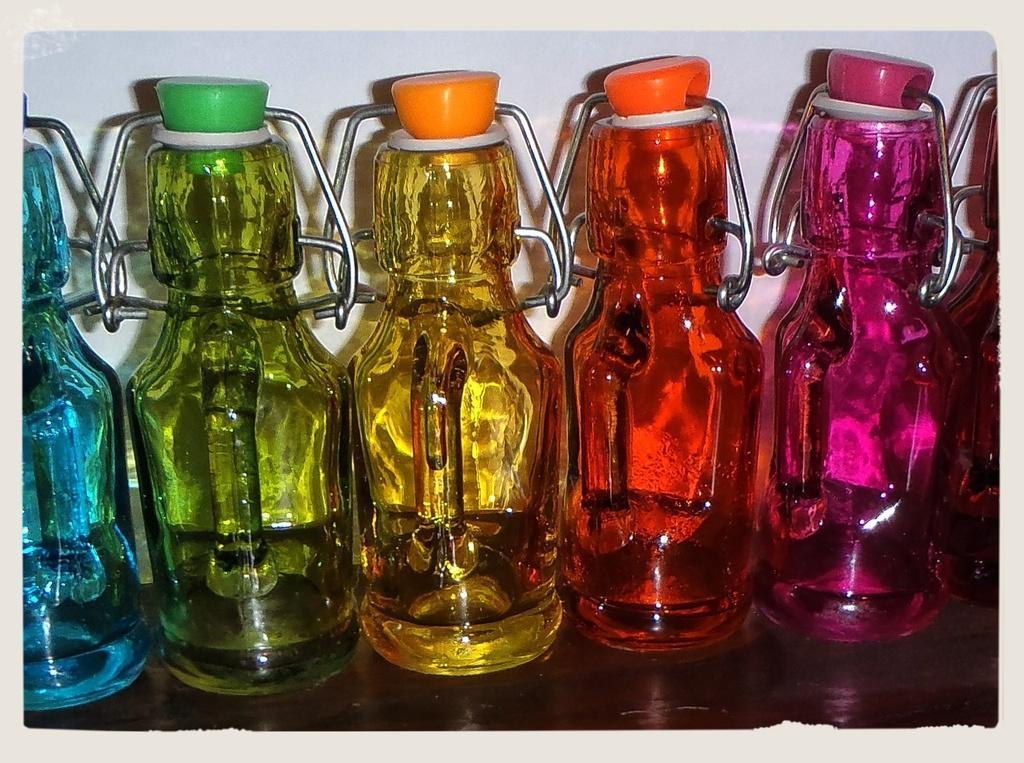Can you describe this image briefly? In the image there are some bottles on the table they are in different colors. Behind the bottles there's a wall. 